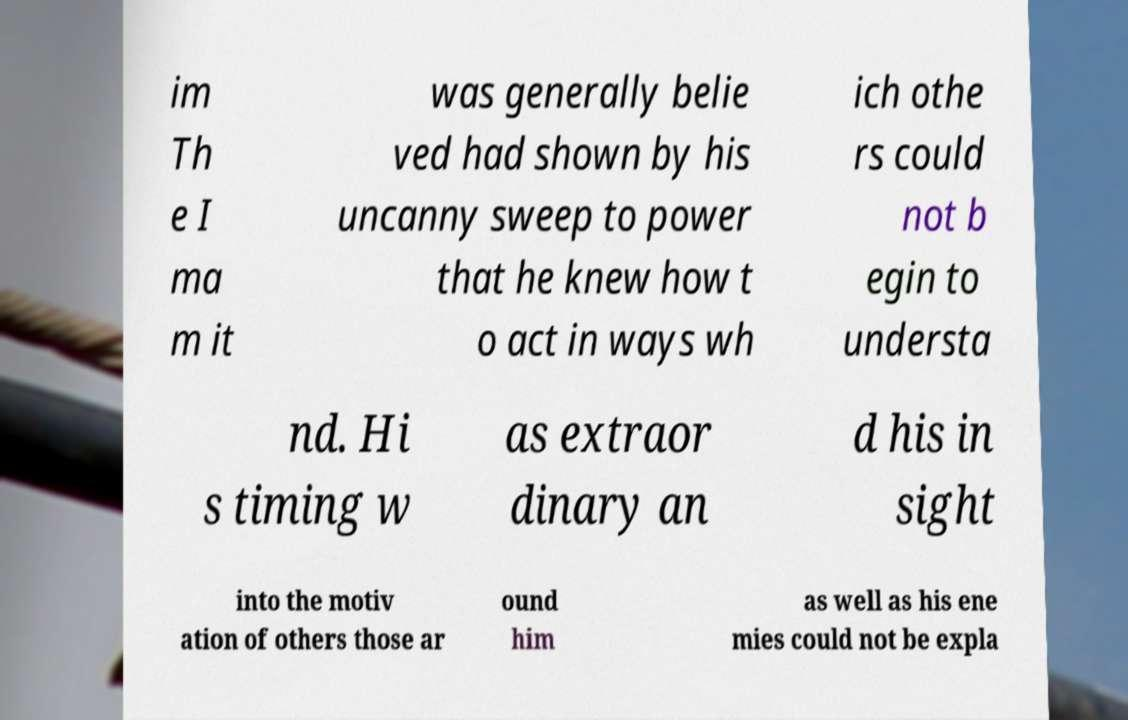Please identify and transcribe the text found in this image. im Th e I ma m it was generally belie ved had shown by his uncanny sweep to power that he knew how t o act in ways wh ich othe rs could not b egin to understa nd. Hi s timing w as extraor dinary an d his in sight into the motiv ation of others those ar ound him as well as his ene mies could not be expla 